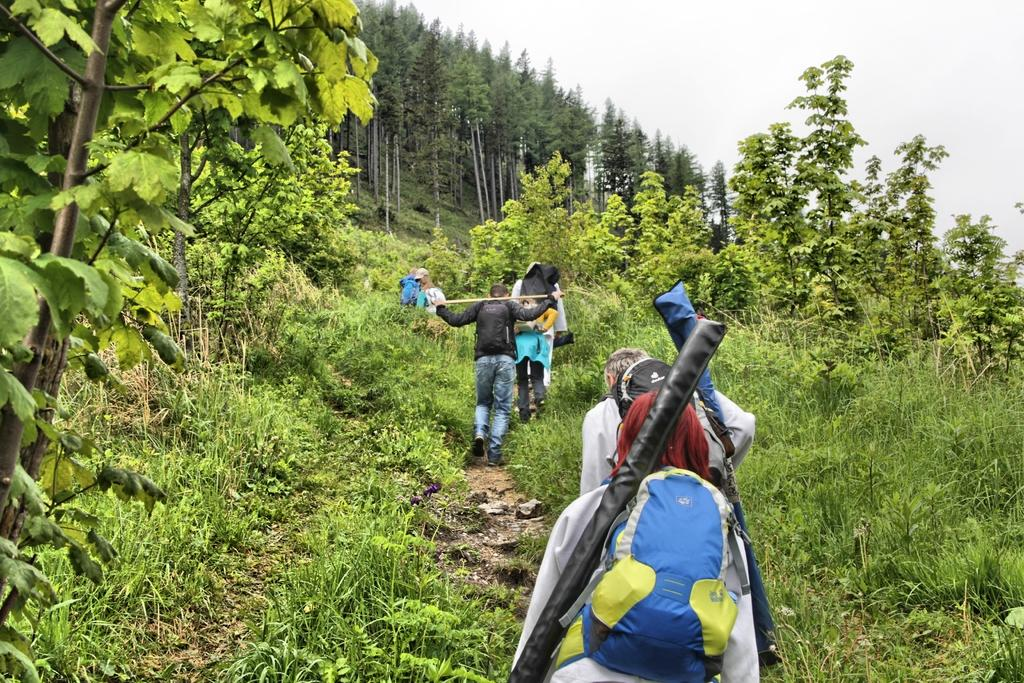What is the surface that the persons are standing on in the image? The ground is covered with grass. What type of vegetation can be seen in the image? There are trees visible in the image. What is visible in the background of the image? The sky is visible in the background. What language is being spoken by the persons in the image? There is no indication of any spoken language in the image, as it only shows persons standing on grass with trees and the sky visible in the background. 